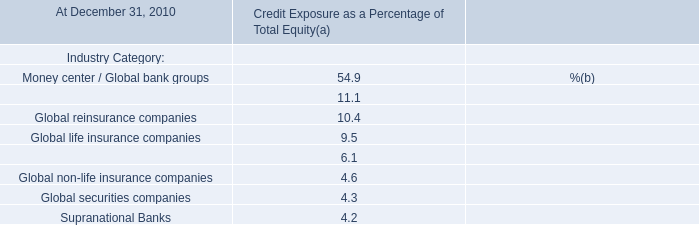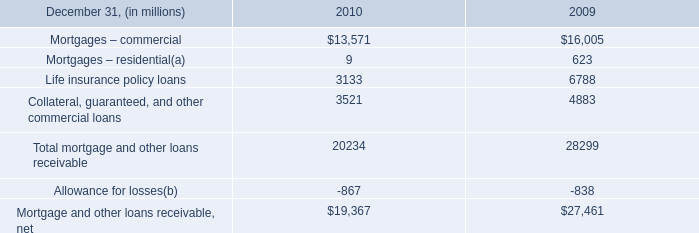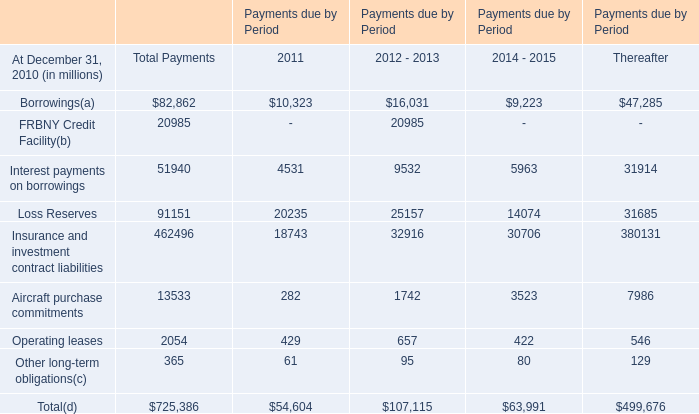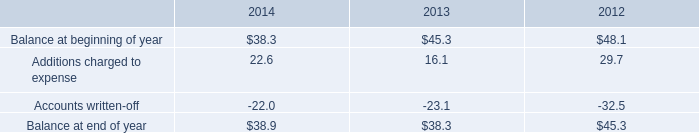what was the percentage decline in the allowance for doubtful accounts in 2013 
Computations: ((38.3 - 45.3) / 45.3)
Answer: -0.15453. 